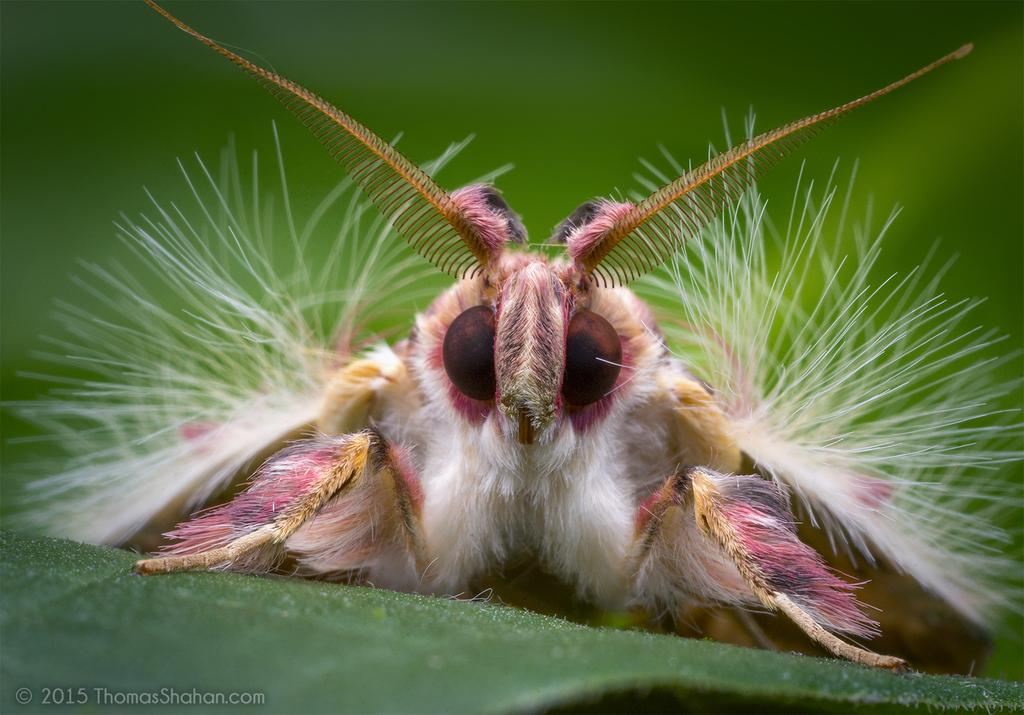What is located on the leaf in the image? There is an insect on a leaf in the image. What else can be seen in the image besides the insect and leaf? There is some text at the bottom of the image. What type of machine is playing songs in the image? There is no machine or songs present in the image; it features an insect on a leaf and some text at the bottom. 